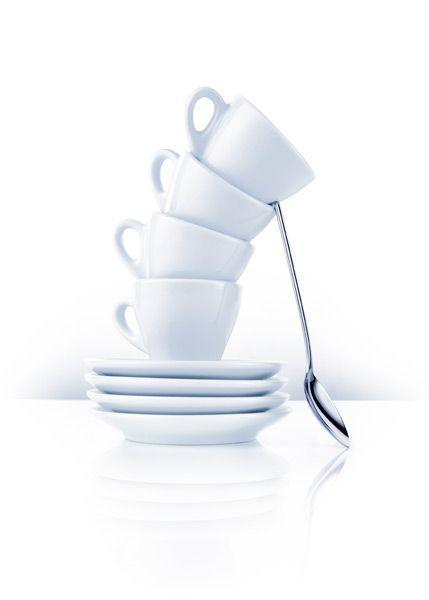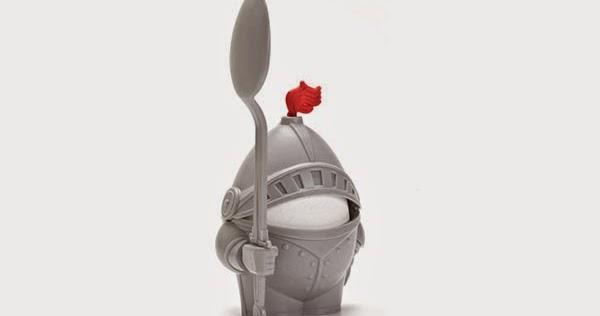The first image is the image on the left, the second image is the image on the right. Examine the images to the left and right. Is the description "The egg in the image on the right is brown." accurate? Answer yes or no. No. 